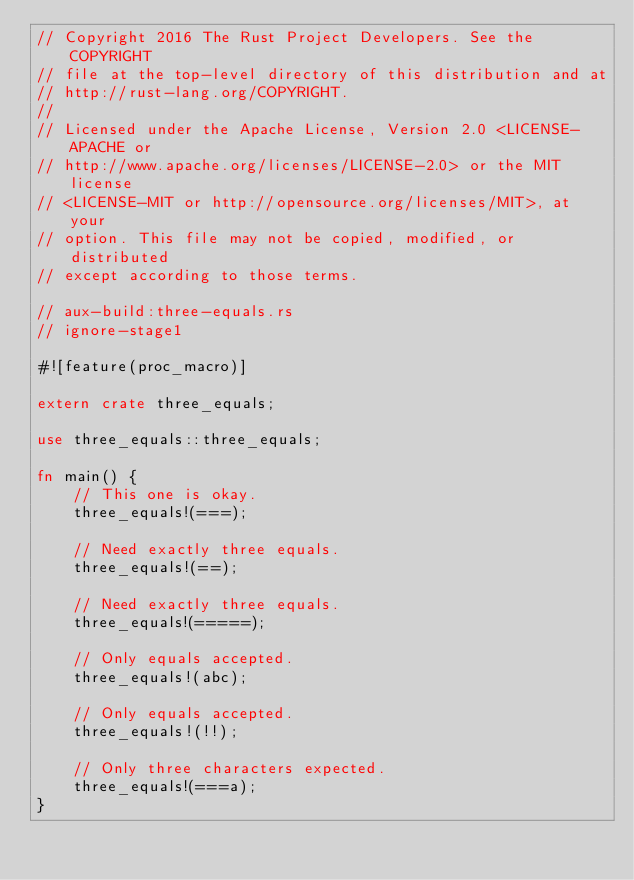<code> <loc_0><loc_0><loc_500><loc_500><_Rust_>// Copyright 2016 The Rust Project Developers. See the COPYRIGHT
// file at the top-level directory of this distribution and at
// http://rust-lang.org/COPYRIGHT.
//
// Licensed under the Apache License, Version 2.0 <LICENSE-APACHE or
// http://www.apache.org/licenses/LICENSE-2.0> or the MIT license
// <LICENSE-MIT or http://opensource.org/licenses/MIT>, at your
// option. This file may not be copied, modified, or distributed
// except according to those terms.

// aux-build:three-equals.rs
// ignore-stage1

#![feature(proc_macro)]

extern crate three_equals;

use three_equals::three_equals;

fn main() {
    // This one is okay.
    three_equals!(===);

    // Need exactly three equals.
    three_equals!(==);

    // Need exactly three equals.
    three_equals!(=====);

    // Only equals accepted.
    three_equals!(abc);

    // Only equals accepted.
    three_equals!(!!);

    // Only three characters expected.
    three_equals!(===a);
}
</code> 